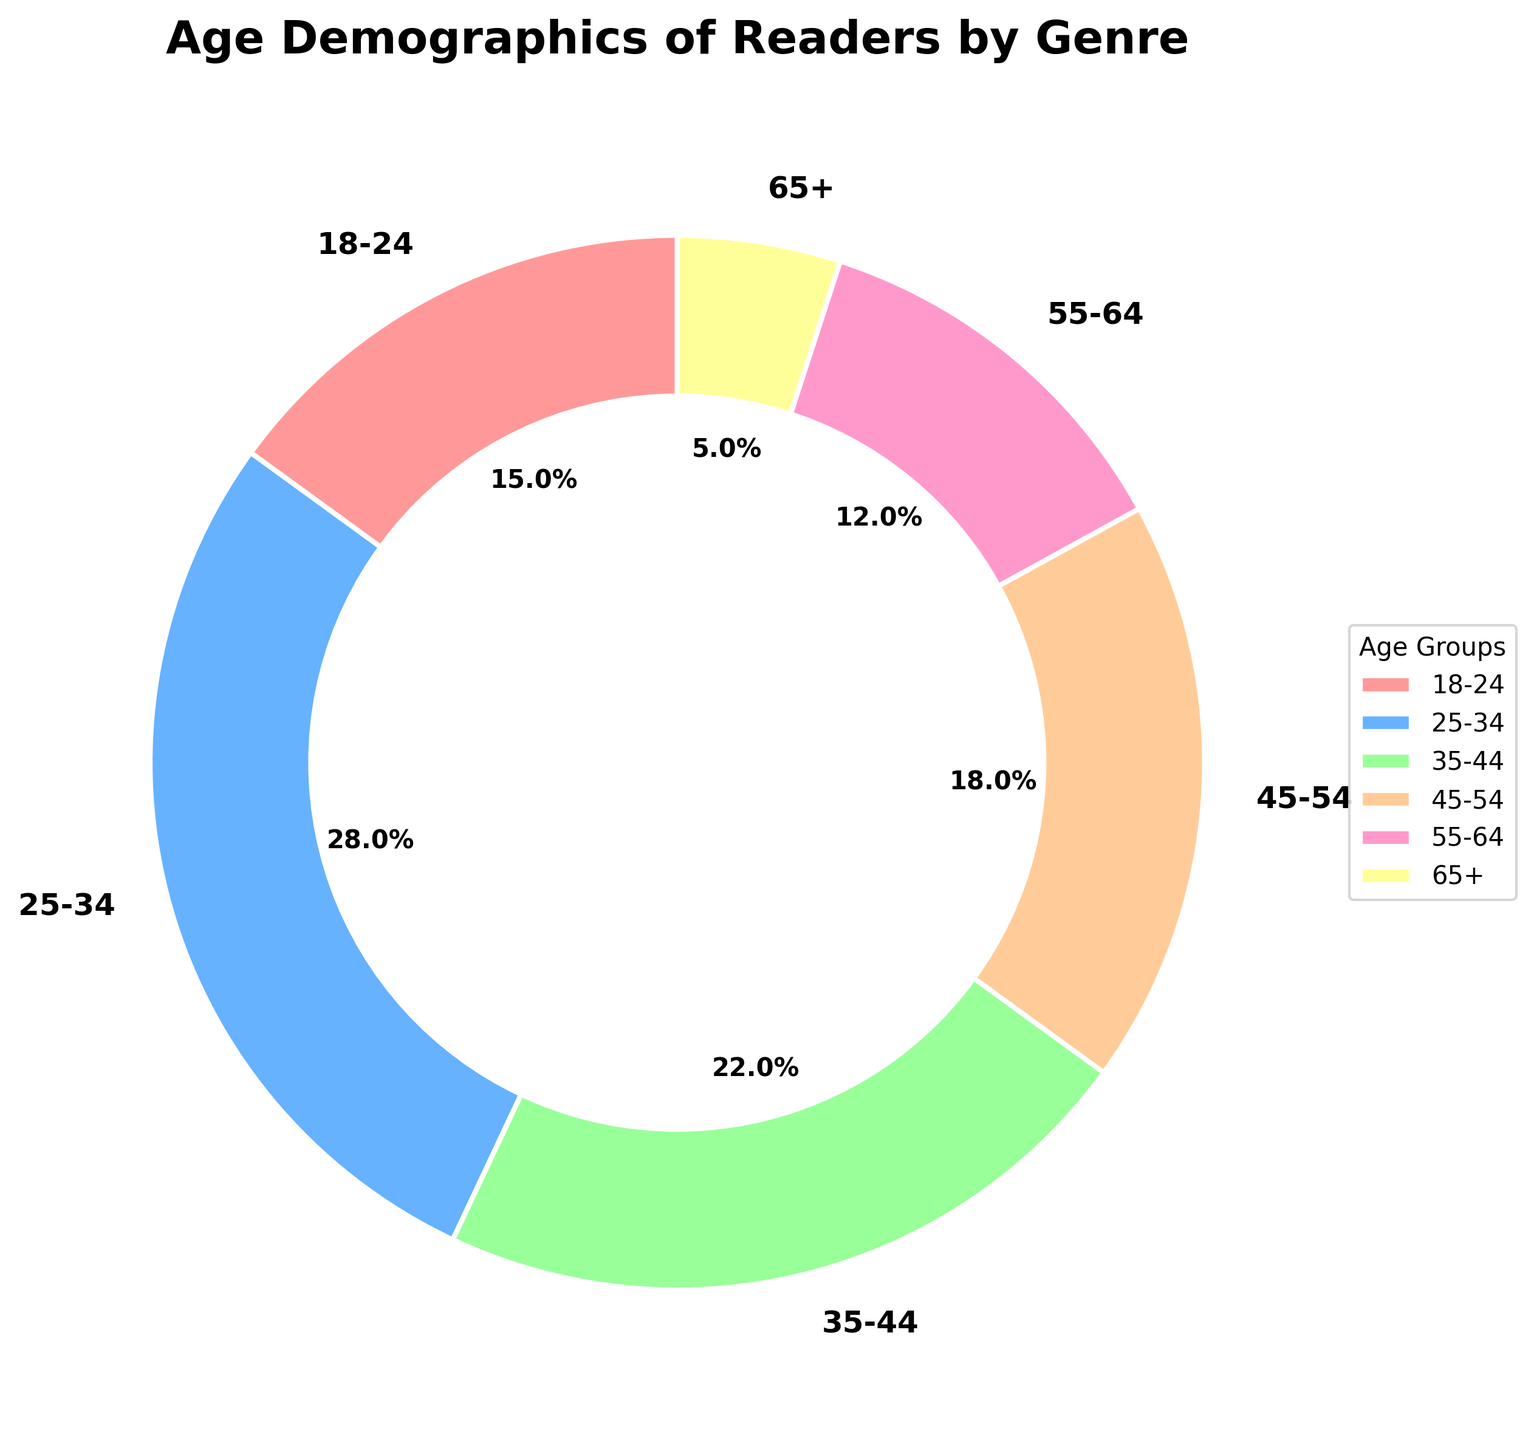Which age group has the highest percentage of readers? The pie chart shows the percentages for each age group. The age group 25-34 has the highest percentage at 28%.
Answer: 25-34 What is the combined percentage of readers aged 45 and above? Adding the percentages of the groups 45-54 (18%), 55-64 (12%), and 65+ (5%) gives 18 + 12 + 5 = 35%.
Answer: 35% Is the percentage of readers aged 18-24 greater than those aged 55-64? Comparing the two age groups: 18-24 has 15% and 55-64 has 12%. Since 15% > 12%, the percentage of readers aged 18-24 is greater.
Answer: Yes What's the difference in percentage between the age groups 25-34 and 35-44? Subtracting the percentage of 35-44 (22%) from 25-34 (28%) gives 28 - 22 = 6%.
Answer: 6% Compare the combined percentage of readers aged 18-34 to those aged 35 and above. Adding the percentages for 18-24 (15%) and 25-34 (28%) gives 15 + 28 = 43%. Adding the percentages for 35-44 (22%), 45-54 (18%), 55-64 (12%), and 65+ (5%) gives 22 + 18 + 12 + 5 = 57%. 43% < 57%.
Answer: Readers aged 35 and above have a higher combined percentage What is the percentage of the age group represented by the green section in the pie chart? The green section represents the age group 35-44, which has a percentage of 22%.
Answer: 22% Which age group has the smallest percentage of readers? The pie chart indicates that the age group 65+ has the smallest percentage of readers, at 5%.
Answer: 65+ What is the average percentage of readers for all age groups? Summing all percentages (15 + 28 + 22 + 18 + 12 + 5) gives 100. Dividing by the number of age groups (6) gives 100 / 6 ≈ 16.67%.
Answer: 16.67% How does the percentage of the 25-34 age group compare to all groups combined except itself? First, excluding the 25-34 group, the remaining percentages add up to 15 + 22 + 18 + 12 + 5 = 72%. So, 28% from 25-34 is less than 72%.
Answer: 25-34 is less than the combined remaining groups 